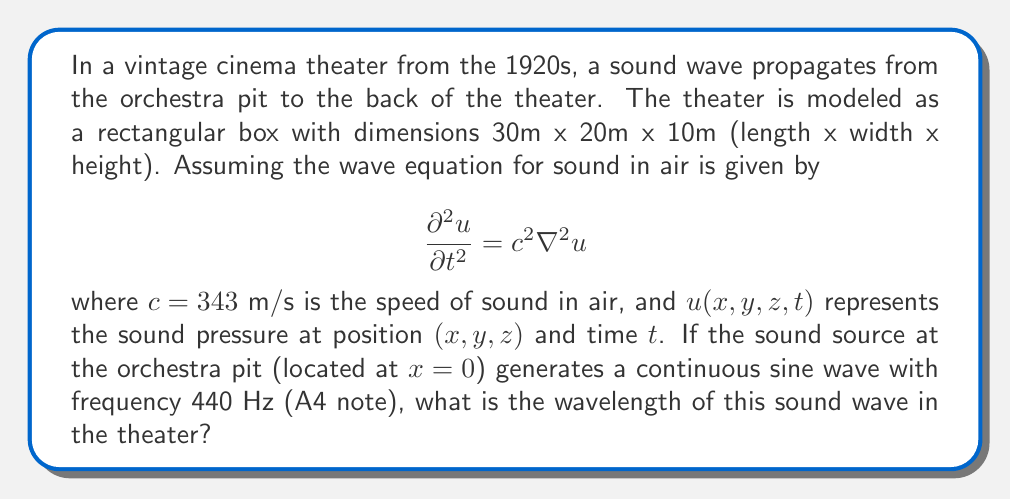What is the answer to this math problem? To solve this problem, we'll follow these steps:

1) First, recall the relationship between wavelength ($\lambda$), frequency ($f$), and wave speed ($c$):

   $$ c = f\lambda $$

2) We're given the speed of sound in air, $c = 343$ m/s, and the frequency of the A4 note, $f = 440$ Hz.

3) Substituting these values into the equation:

   $$ 343 = 440\lambda $$

4) Now, we can solve for $\lambda$:

   $$ \lambda = \frac{343}{440} $$

5) Calculating this:

   $$ \lambda \approx 0.7795454545 \text{ m} $$

6) Rounding to three decimal places:

   $$ \lambda \approx 0.780 \text{ m} $$

This wavelength represents the spatial period of the sound wave as it propagates through the vintage cinema theater, helping us visualize how the sound would have behaved in early cinema settings.
Answer: $0.780$ m 